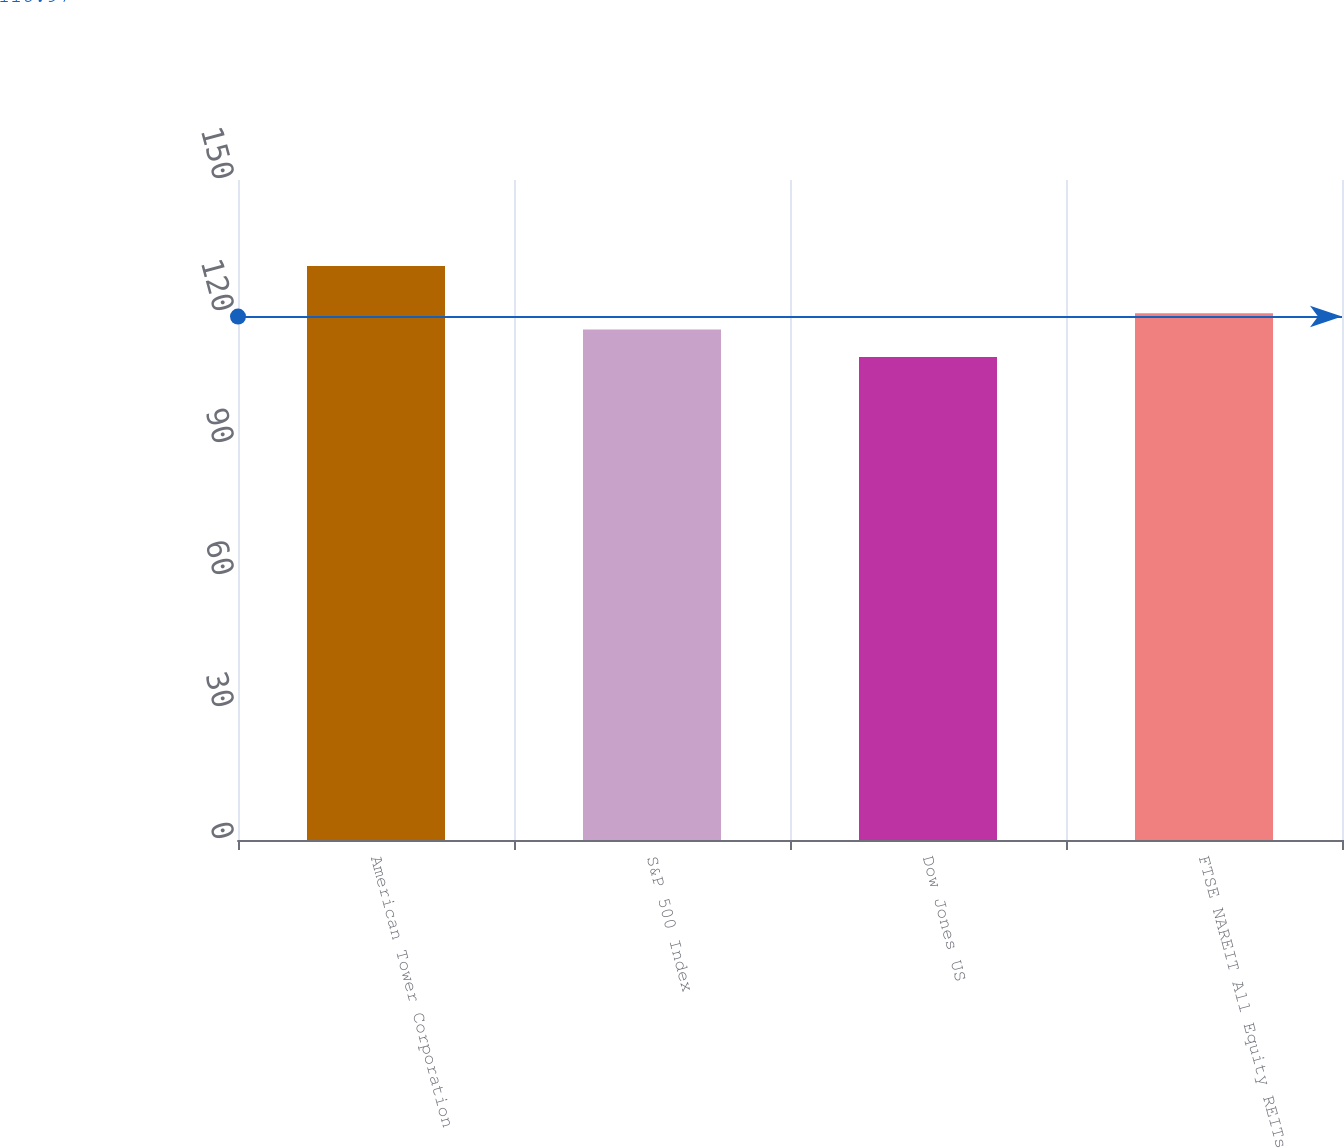Convert chart. <chart><loc_0><loc_0><loc_500><loc_500><bar_chart><fcel>American Tower Corporation<fcel>S&P 500 Index<fcel>Dow Jones US<fcel>FTSE NAREIT All Equity REITs<nl><fcel>130.43<fcel>116<fcel>109.75<fcel>119.7<nl></chart> 